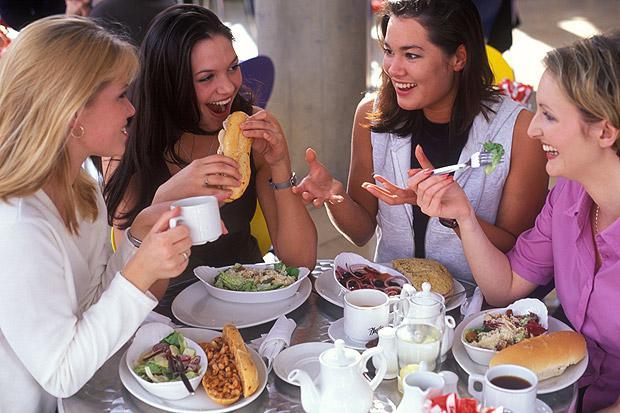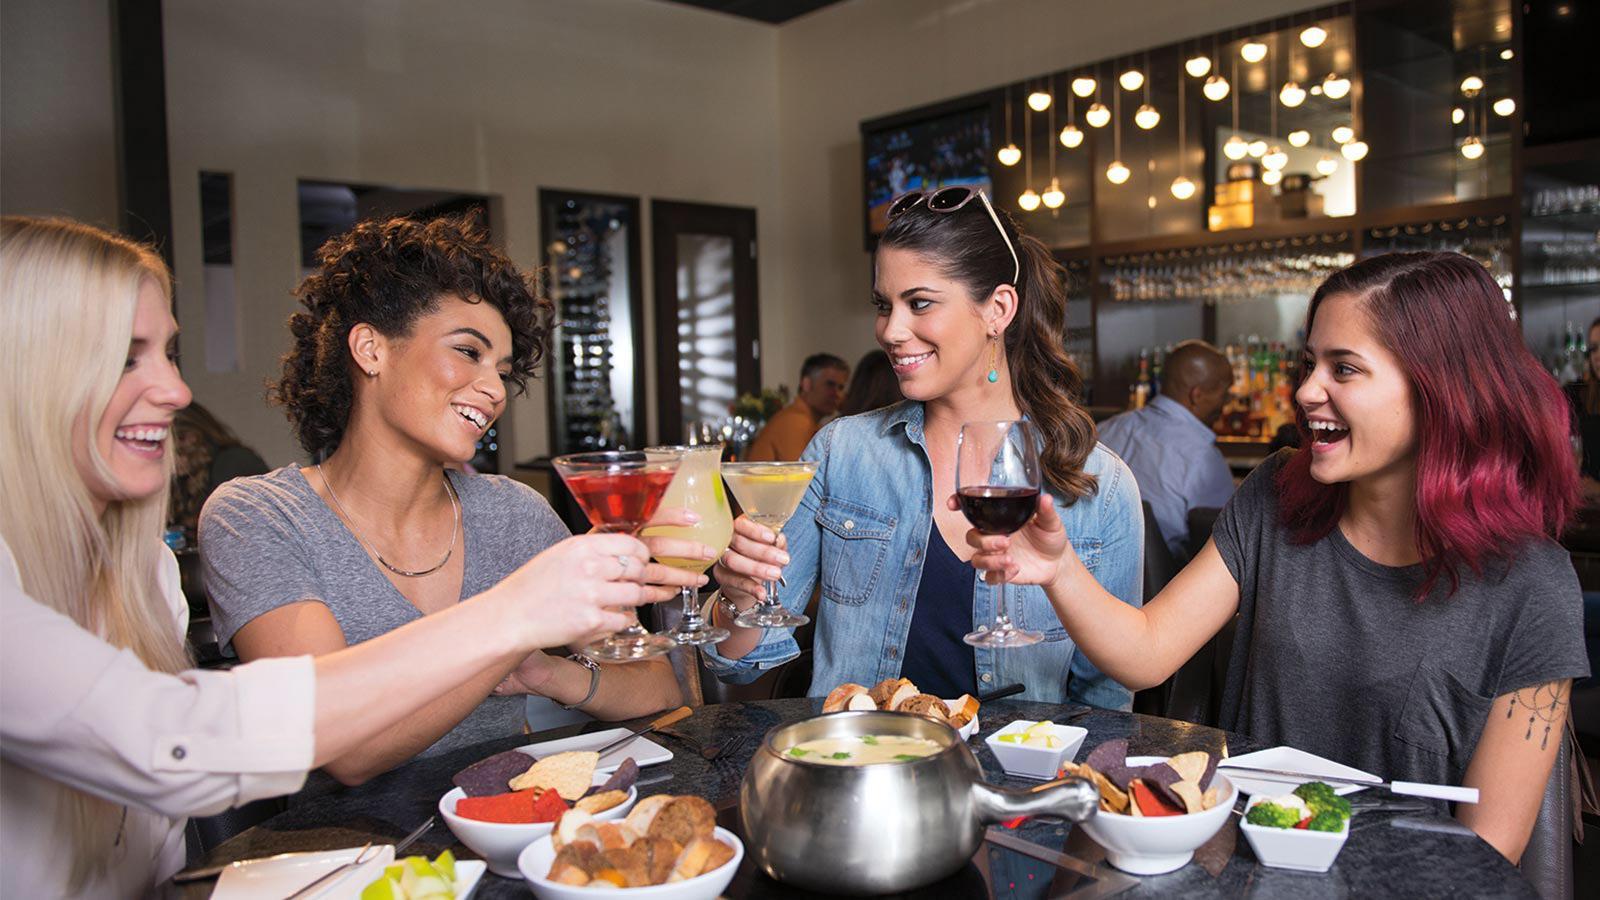The first image is the image on the left, the second image is the image on the right. Given the left and right images, does the statement "The woman on the right at a table is lifting a forkful of food above a white plate, in the lefthand image." hold true? Answer yes or no. Yes. The first image is the image on the left, the second image is the image on the right. Given the left and right images, does the statement "The people around the tables are looking at each other and not the camera." hold true? Answer yes or no. Yes. 